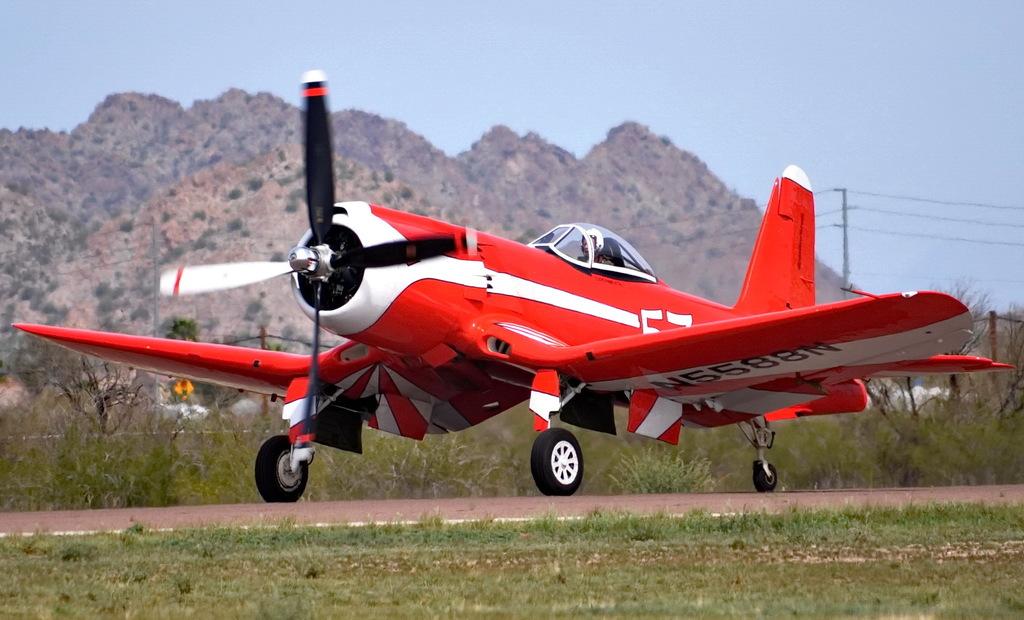Does this plane state that it's easy?
Your answer should be compact. No. What is the id number on the bottom of the wing?
Give a very brief answer. N5588n. 